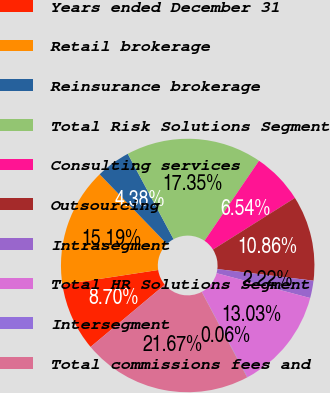<chart> <loc_0><loc_0><loc_500><loc_500><pie_chart><fcel>Years ended December 31<fcel>Retail brokerage<fcel>Reinsurance brokerage<fcel>Total Risk Solutions Segment<fcel>Consulting services<fcel>Outsourcing<fcel>Intrasegment<fcel>Total HR Solutions Segment<fcel>Intersegment<fcel>Total commissions fees and<nl><fcel>8.7%<fcel>15.19%<fcel>4.38%<fcel>17.35%<fcel>6.54%<fcel>10.86%<fcel>2.22%<fcel>13.03%<fcel>0.06%<fcel>21.67%<nl></chart> 